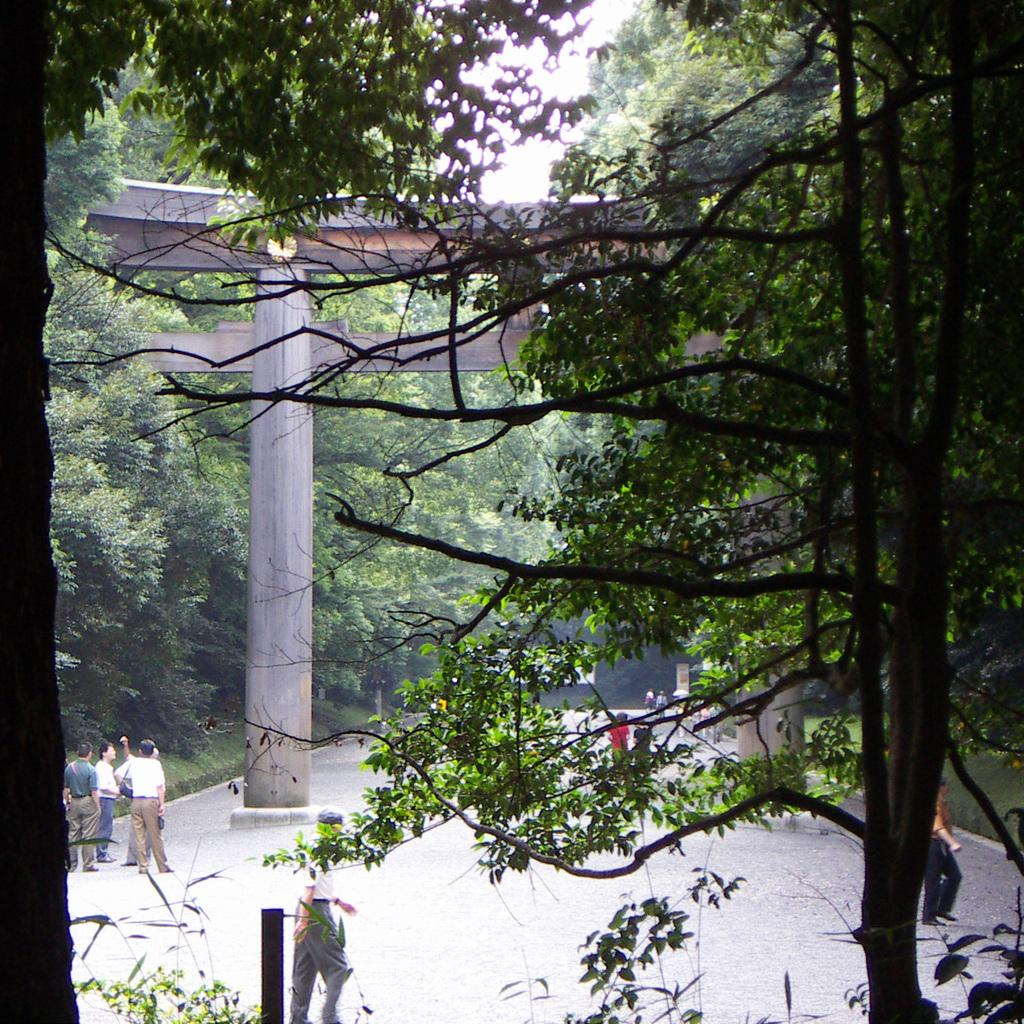What type of vegetation can be seen in the image? There are trees in the image. What are the people in the image doing? The people are standing on the ground in the image. What architectural features are visible in the image? Pillars are visible in the image. What type of lighting is present in the image? A street light is present in the image. What can be seen in the background of the image? The sky is visible in the background of the image. What type of yam is being used to light the street light in the image? There is no yam present in the image, and yams are not used to light street lights. Can you see a plane flying in the sky in the image? There is no plane visible in the sky in the image. 